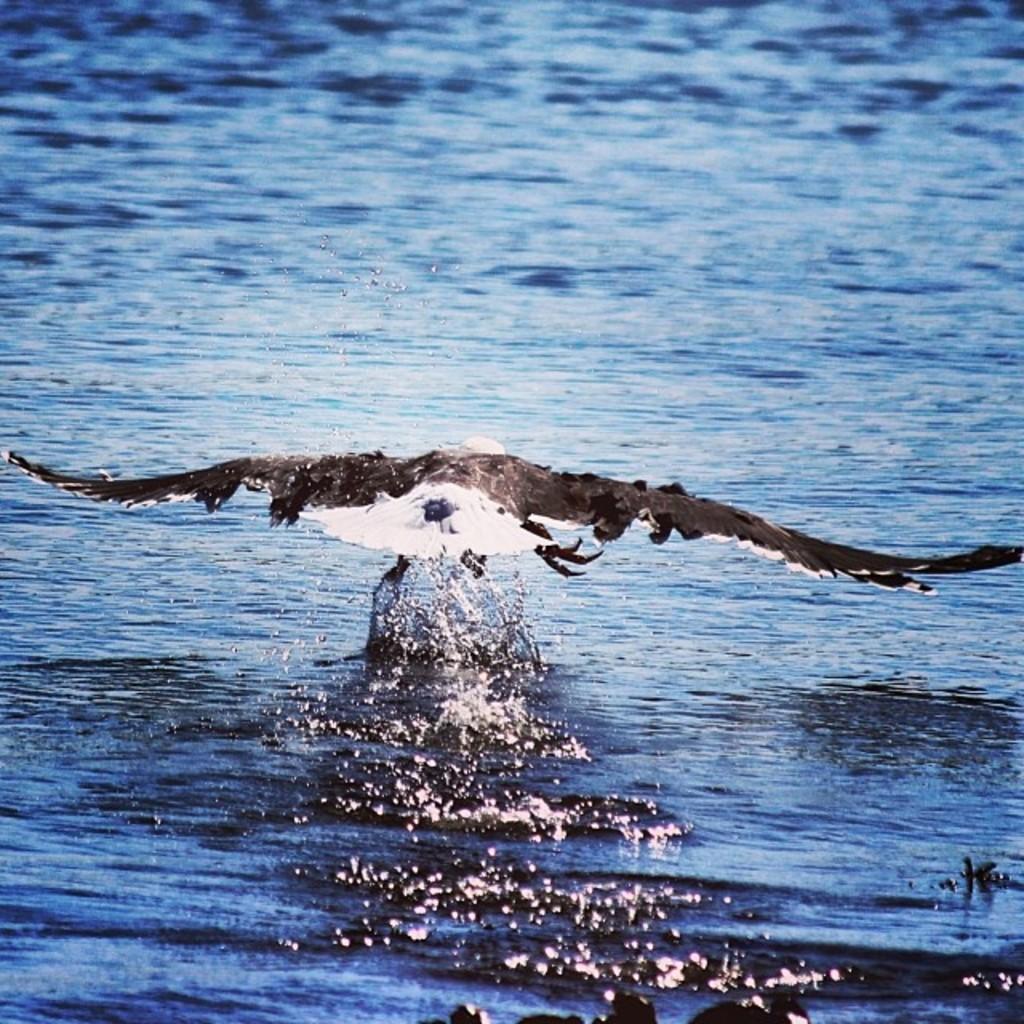How would you summarize this image in a sentence or two? In the image we can see a bird, white and black in color. This is water, blue in color. 